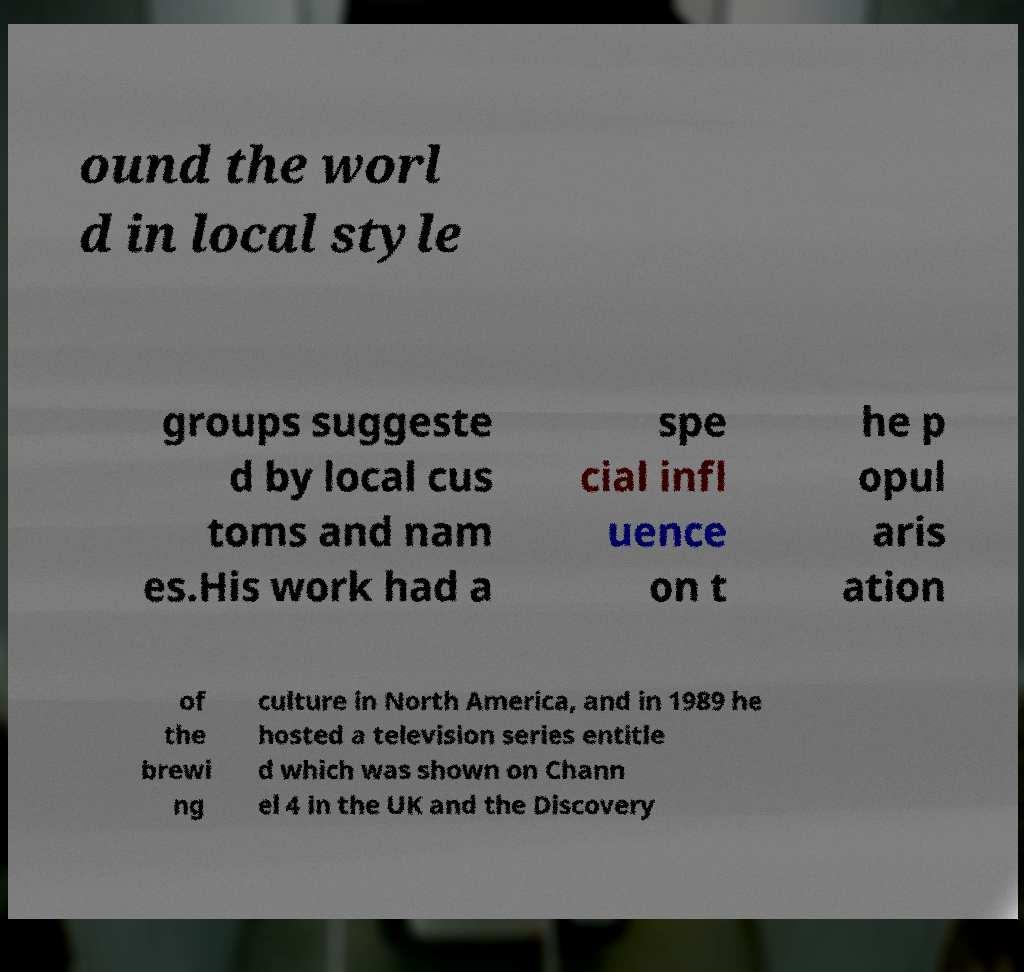Can you read and provide the text displayed in the image?This photo seems to have some interesting text. Can you extract and type it out for me? ound the worl d in local style groups suggeste d by local cus toms and nam es.His work had a spe cial infl uence on t he p opul aris ation of the brewi ng culture in North America, and in 1989 he hosted a television series entitle d which was shown on Chann el 4 in the UK and the Discovery 